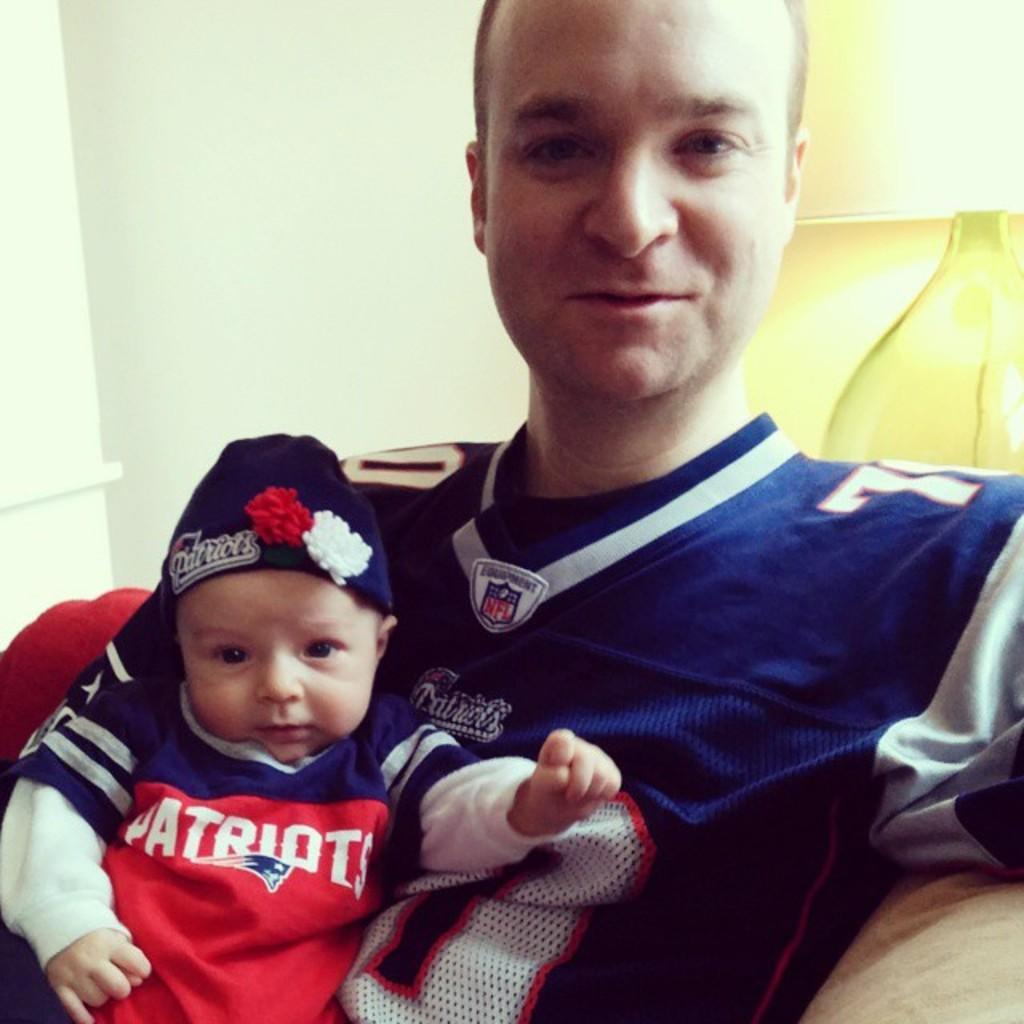Who is present in the image? There is a man in the image. What is located on the left side of the image? There is a baby on the left side of the image. What is the man's facial expression in the image? The man is smiling in the image. What can be seen in the background of the image? There is a wall in the background of the image. What type of line can be seen connecting the man and the baby in the image? There is no line connecting the man and the baby in the image. What kind of banana is the man holding in the image? There is no banana present in the image. 